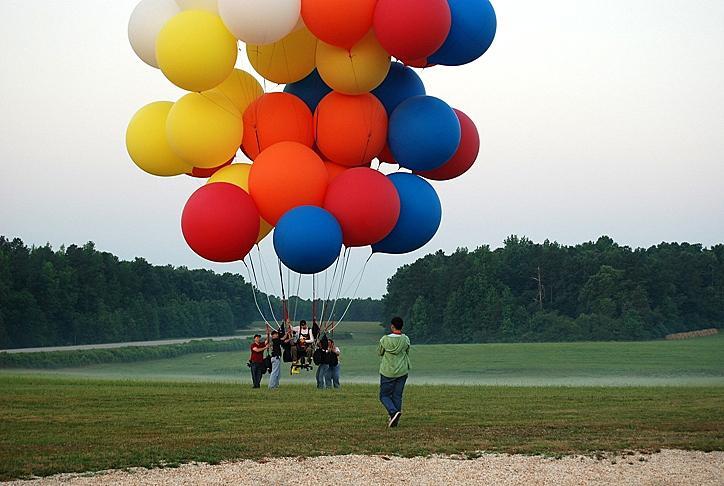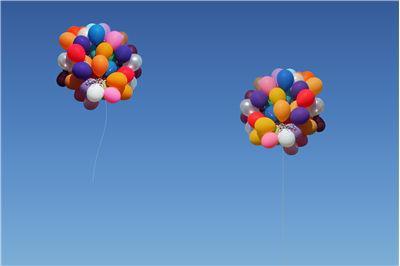The first image is the image on the left, the second image is the image on the right. Evaluate the accuracy of this statement regarding the images: "There are three bunches of balloons.". Is it true? Answer yes or no. Yes. The first image is the image on the left, the second image is the image on the right. Analyze the images presented: Is the assertion "Two balloon bunches containing at least a dozen balloons each are in the air in one image." valid? Answer yes or no. Yes. 